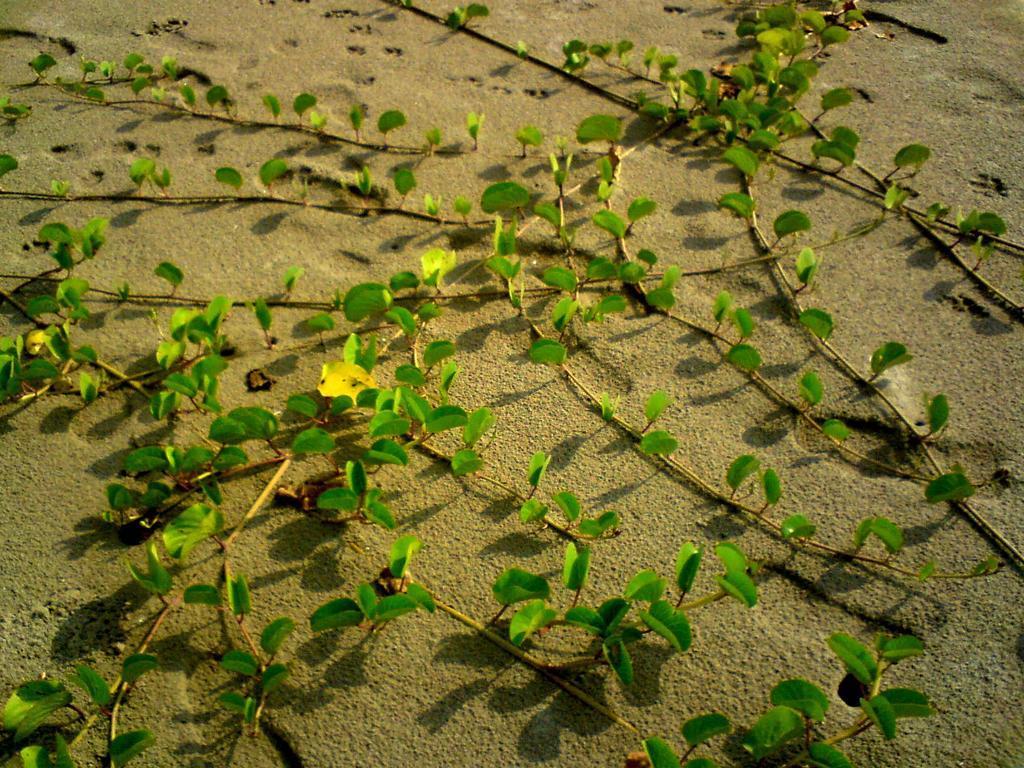In one or two sentences, can you explain what this image depicts? In this image I can see few plants on the sand. I can see few footprints on the sand. 